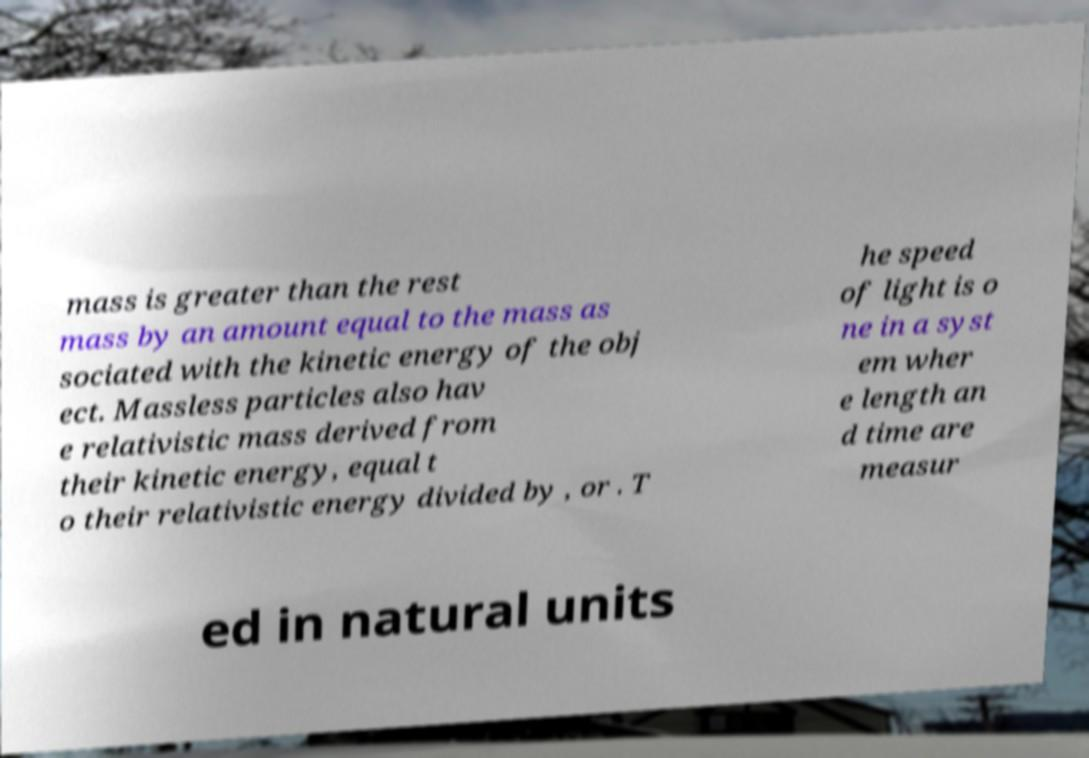Please read and relay the text visible in this image. What does it say? mass is greater than the rest mass by an amount equal to the mass as sociated with the kinetic energy of the obj ect. Massless particles also hav e relativistic mass derived from their kinetic energy, equal t o their relativistic energy divided by , or . T he speed of light is o ne in a syst em wher e length an d time are measur ed in natural units 